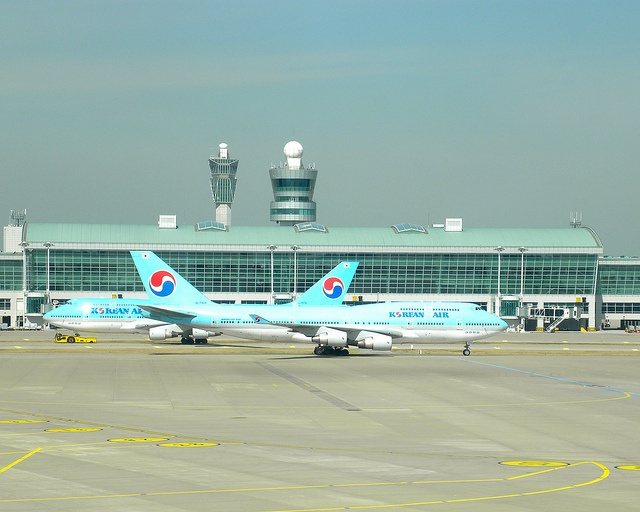Describe the objects in this image and their specific colors. I can see airplane in lightblue, white, cyan, darkgray, and gray tones, airplane in lightblue, cyan, white, and darkgray tones, and car in lightblue, gold, olive, and black tones in this image. 